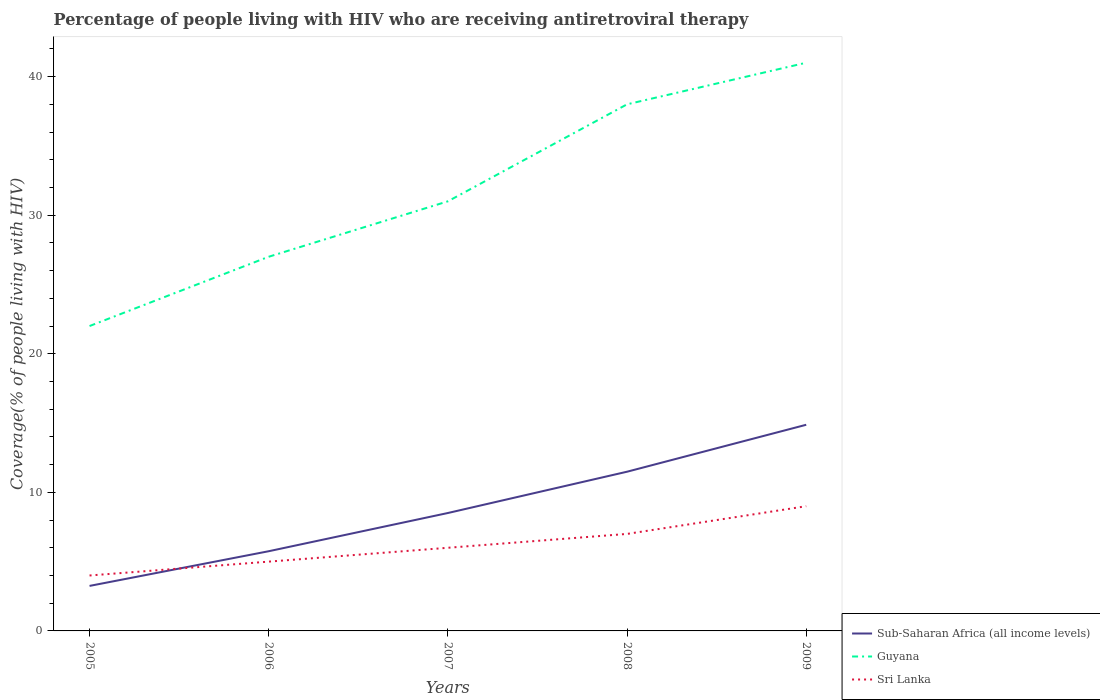Across all years, what is the maximum percentage of the HIV infected people who are receiving antiretroviral therapy in Sri Lanka?
Offer a terse response. 4. What is the total percentage of the HIV infected people who are receiving antiretroviral therapy in Sub-Saharan Africa (all income levels) in the graph?
Your response must be concise. -2.98. What is the difference between the highest and the second highest percentage of the HIV infected people who are receiving antiretroviral therapy in Sri Lanka?
Your response must be concise. 5. Is the percentage of the HIV infected people who are receiving antiretroviral therapy in Sri Lanka strictly greater than the percentage of the HIV infected people who are receiving antiretroviral therapy in Guyana over the years?
Keep it short and to the point. Yes. How many lines are there?
Your answer should be very brief. 3. What is the difference between two consecutive major ticks on the Y-axis?
Make the answer very short. 10. Are the values on the major ticks of Y-axis written in scientific E-notation?
Offer a very short reply. No. Does the graph contain any zero values?
Your answer should be very brief. No. How many legend labels are there?
Offer a very short reply. 3. What is the title of the graph?
Give a very brief answer. Percentage of people living with HIV who are receiving antiretroviral therapy. What is the label or title of the X-axis?
Make the answer very short. Years. What is the label or title of the Y-axis?
Offer a terse response. Coverage(% of people living with HIV). What is the Coverage(% of people living with HIV) in Sub-Saharan Africa (all income levels) in 2005?
Offer a terse response. 3.25. What is the Coverage(% of people living with HIV) of Sub-Saharan Africa (all income levels) in 2006?
Your response must be concise. 5.75. What is the Coverage(% of people living with HIV) in Sub-Saharan Africa (all income levels) in 2007?
Offer a terse response. 8.51. What is the Coverage(% of people living with HIV) of Sri Lanka in 2007?
Provide a short and direct response. 6. What is the Coverage(% of people living with HIV) in Sub-Saharan Africa (all income levels) in 2008?
Provide a succinct answer. 11.49. What is the Coverage(% of people living with HIV) in Guyana in 2008?
Offer a terse response. 38. What is the Coverage(% of people living with HIV) in Sub-Saharan Africa (all income levels) in 2009?
Ensure brevity in your answer.  14.88. What is the Coverage(% of people living with HIV) in Sri Lanka in 2009?
Ensure brevity in your answer.  9. Across all years, what is the maximum Coverage(% of people living with HIV) in Sub-Saharan Africa (all income levels)?
Your answer should be compact. 14.88. Across all years, what is the minimum Coverage(% of people living with HIV) of Sub-Saharan Africa (all income levels)?
Give a very brief answer. 3.25. What is the total Coverage(% of people living with HIV) in Sub-Saharan Africa (all income levels) in the graph?
Provide a succinct answer. 43.87. What is the total Coverage(% of people living with HIV) of Guyana in the graph?
Give a very brief answer. 159. What is the total Coverage(% of people living with HIV) in Sri Lanka in the graph?
Keep it short and to the point. 31. What is the difference between the Coverage(% of people living with HIV) of Sub-Saharan Africa (all income levels) in 2005 and that in 2006?
Your response must be concise. -2.5. What is the difference between the Coverage(% of people living with HIV) of Guyana in 2005 and that in 2006?
Provide a short and direct response. -5. What is the difference between the Coverage(% of people living with HIV) of Sri Lanka in 2005 and that in 2006?
Your answer should be very brief. -1. What is the difference between the Coverage(% of people living with HIV) of Sub-Saharan Africa (all income levels) in 2005 and that in 2007?
Your answer should be compact. -5.26. What is the difference between the Coverage(% of people living with HIV) of Sub-Saharan Africa (all income levels) in 2005 and that in 2008?
Offer a very short reply. -8.24. What is the difference between the Coverage(% of people living with HIV) in Sri Lanka in 2005 and that in 2008?
Your response must be concise. -3. What is the difference between the Coverage(% of people living with HIV) in Sub-Saharan Africa (all income levels) in 2005 and that in 2009?
Make the answer very short. -11.63. What is the difference between the Coverage(% of people living with HIV) in Sri Lanka in 2005 and that in 2009?
Keep it short and to the point. -5. What is the difference between the Coverage(% of people living with HIV) of Sub-Saharan Africa (all income levels) in 2006 and that in 2007?
Provide a succinct answer. -2.76. What is the difference between the Coverage(% of people living with HIV) of Guyana in 2006 and that in 2007?
Make the answer very short. -4. What is the difference between the Coverage(% of people living with HIV) in Sub-Saharan Africa (all income levels) in 2006 and that in 2008?
Give a very brief answer. -5.74. What is the difference between the Coverage(% of people living with HIV) of Guyana in 2006 and that in 2008?
Provide a short and direct response. -11. What is the difference between the Coverage(% of people living with HIV) of Sub-Saharan Africa (all income levels) in 2006 and that in 2009?
Your response must be concise. -9.12. What is the difference between the Coverage(% of people living with HIV) of Guyana in 2006 and that in 2009?
Your response must be concise. -14. What is the difference between the Coverage(% of people living with HIV) in Sub-Saharan Africa (all income levels) in 2007 and that in 2008?
Keep it short and to the point. -2.98. What is the difference between the Coverage(% of people living with HIV) of Guyana in 2007 and that in 2008?
Make the answer very short. -7. What is the difference between the Coverage(% of people living with HIV) in Sri Lanka in 2007 and that in 2008?
Offer a very short reply. -1. What is the difference between the Coverage(% of people living with HIV) of Sub-Saharan Africa (all income levels) in 2007 and that in 2009?
Give a very brief answer. -6.37. What is the difference between the Coverage(% of people living with HIV) of Guyana in 2007 and that in 2009?
Make the answer very short. -10. What is the difference between the Coverage(% of people living with HIV) of Sri Lanka in 2007 and that in 2009?
Offer a terse response. -3. What is the difference between the Coverage(% of people living with HIV) of Sub-Saharan Africa (all income levels) in 2008 and that in 2009?
Give a very brief answer. -3.39. What is the difference between the Coverage(% of people living with HIV) of Guyana in 2008 and that in 2009?
Provide a short and direct response. -3. What is the difference between the Coverage(% of people living with HIV) in Sri Lanka in 2008 and that in 2009?
Provide a succinct answer. -2. What is the difference between the Coverage(% of people living with HIV) of Sub-Saharan Africa (all income levels) in 2005 and the Coverage(% of people living with HIV) of Guyana in 2006?
Provide a short and direct response. -23.75. What is the difference between the Coverage(% of people living with HIV) of Sub-Saharan Africa (all income levels) in 2005 and the Coverage(% of people living with HIV) of Sri Lanka in 2006?
Provide a succinct answer. -1.75. What is the difference between the Coverage(% of people living with HIV) in Sub-Saharan Africa (all income levels) in 2005 and the Coverage(% of people living with HIV) in Guyana in 2007?
Provide a succinct answer. -27.75. What is the difference between the Coverage(% of people living with HIV) in Sub-Saharan Africa (all income levels) in 2005 and the Coverage(% of people living with HIV) in Sri Lanka in 2007?
Ensure brevity in your answer.  -2.75. What is the difference between the Coverage(% of people living with HIV) of Guyana in 2005 and the Coverage(% of people living with HIV) of Sri Lanka in 2007?
Offer a very short reply. 16. What is the difference between the Coverage(% of people living with HIV) of Sub-Saharan Africa (all income levels) in 2005 and the Coverage(% of people living with HIV) of Guyana in 2008?
Provide a succinct answer. -34.75. What is the difference between the Coverage(% of people living with HIV) of Sub-Saharan Africa (all income levels) in 2005 and the Coverage(% of people living with HIV) of Sri Lanka in 2008?
Your response must be concise. -3.75. What is the difference between the Coverage(% of people living with HIV) of Sub-Saharan Africa (all income levels) in 2005 and the Coverage(% of people living with HIV) of Guyana in 2009?
Offer a very short reply. -37.75. What is the difference between the Coverage(% of people living with HIV) in Sub-Saharan Africa (all income levels) in 2005 and the Coverage(% of people living with HIV) in Sri Lanka in 2009?
Keep it short and to the point. -5.75. What is the difference between the Coverage(% of people living with HIV) of Sub-Saharan Africa (all income levels) in 2006 and the Coverage(% of people living with HIV) of Guyana in 2007?
Offer a very short reply. -25.25. What is the difference between the Coverage(% of people living with HIV) of Sub-Saharan Africa (all income levels) in 2006 and the Coverage(% of people living with HIV) of Sri Lanka in 2007?
Provide a succinct answer. -0.25. What is the difference between the Coverage(% of people living with HIV) in Sub-Saharan Africa (all income levels) in 2006 and the Coverage(% of people living with HIV) in Guyana in 2008?
Give a very brief answer. -32.25. What is the difference between the Coverage(% of people living with HIV) in Sub-Saharan Africa (all income levels) in 2006 and the Coverage(% of people living with HIV) in Sri Lanka in 2008?
Offer a very short reply. -1.25. What is the difference between the Coverage(% of people living with HIV) of Sub-Saharan Africa (all income levels) in 2006 and the Coverage(% of people living with HIV) of Guyana in 2009?
Offer a very short reply. -35.25. What is the difference between the Coverage(% of people living with HIV) in Sub-Saharan Africa (all income levels) in 2006 and the Coverage(% of people living with HIV) in Sri Lanka in 2009?
Offer a terse response. -3.25. What is the difference between the Coverage(% of people living with HIV) in Sub-Saharan Africa (all income levels) in 2007 and the Coverage(% of people living with HIV) in Guyana in 2008?
Provide a succinct answer. -29.49. What is the difference between the Coverage(% of people living with HIV) of Sub-Saharan Africa (all income levels) in 2007 and the Coverage(% of people living with HIV) of Sri Lanka in 2008?
Keep it short and to the point. 1.51. What is the difference between the Coverage(% of people living with HIV) in Sub-Saharan Africa (all income levels) in 2007 and the Coverage(% of people living with HIV) in Guyana in 2009?
Give a very brief answer. -32.49. What is the difference between the Coverage(% of people living with HIV) of Sub-Saharan Africa (all income levels) in 2007 and the Coverage(% of people living with HIV) of Sri Lanka in 2009?
Provide a short and direct response. -0.49. What is the difference between the Coverage(% of people living with HIV) in Sub-Saharan Africa (all income levels) in 2008 and the Coverage(% of people living with HIV) in Guyana in 2009?
Your response must be concise. -29.51. What is the difference between the Coverage(% of people living with HIV) in Sub-Saharan Africa (all income levels) in 2008 and the Coverage(% of people living with HIV) in Sri Lanka in 2009?
Provide a succinct answer. 2.49. What is the average Coverage(% of people living with HIV) in Sub-Saharan Africa (all income levels) per year?
Make the answer very short. 8.77. What is the average Coverage(% of people living with HIV) in Guyana per year?
Give a very brief answer. 31.8. In the year 2005, what is the difference between the Coverage(% of people living with HIV) of Sub-Saharan Africa (all income levels) and Coverage(% of people living with HIV) of Guyana?
Offer a terse response. -18.75. In the year 2005, what is the difference between the Coverage(% of people living with HIV) of Sub-Saharan Africa (all income levels) and Coverage(% of people living with HIV) of Sri Lanka?
Give a very brief answer. -0.75. In the year 2005, what is the difference between the Coverage(% of people living with HIV) of Guyana and Coverage(% of people living with HIV) of Sri Lanka?
Offer a terse response. 18. In the year 2006, what is the difference between the Coverage(% of people living with HIV) in Sub-Saharan Africa (all income levels) and Coverage(% of people living with HIV) in Guyana?
Your answer should be compact. -21.25. In the year 2006, what is the difference between the Coverage(% of people living with HIV) of Sub-Saharan Africa (all income levels) and Coverage(% of people living with HIV) of Sri Lanka?
Offer a terse response. 0.75. In the year 2006, what is the difference between the Coverage(% of people living with HIV) in Guyana and Coverage(% of people living with HIV) in Sri Lanka?
Offer a very short reply. 22. In the year 2007, what is the difference between the Coverage(% of people living with HIV) of Sub-Saharan Africa (all income levels) and Coverage(% of people living with HIV) of Guyana?
Provide a short and direct response. -22.49. In the year 2007, what is the difference between the Coverage(% of people living with HIV) in Sub-Saharan Africa (all income levels) and Coverage(% of people living with HIV) in Sri Lanka?
Your response must be concise. 2.51. In the year 2007, what is the difference between the Coverage(% of people living with HIV) in Guyana and Coverage(% of people living with HIV) in Sri Lanka?
Offer a terse response. 25. In the year 2008, what is the difference between the Coverage(% of people living with HIV) of Sub-Saharan Africa (all income levels) and Coverage(% of people living with HIV) of Guyana?
Offer a very short reply. -26.51. In the year 2008, what is the difference between the Coverage(% of people living with HIV) in Sub-Saharan Africa (all income levels) and Coverage(% of people living with HIV) in Sri Lanka?
Ensure brevity in your answer.  4.49. In the year 2008, what is the difference between the Coverage(% of people living with HIV) in Guyana and Coverage(% of people living with HIV) in Sri Lanka?
Provide a short and direct response. 31. In the year 2009, what is the difference between the Coverage(% of people living with HIV) in Sub-Saharan Africa (all income levels) and Coverage(% of people living with HIV) in Guyana?
Offer a terse response. -26.12. In the year 2009, what is the difference between the Coverage(% of people living with HIV) in Sub-Saharan Africa (all income levels) and Coverage(% of people living with HIV) in Sri Lanka?
Give a very brief answer. 5.88. In the year 2009, what is the difference between the Coverage(% of people living with HIV) in Guyana and Coverage(% of people living with HIV) in Sri Lanka?
Give a very brief answer. 32. What is the ratio of the Coverage(% of people living with HIV) of Sub-Saharan Africa (all income levels) in 2005 to that in 2006?
Your response must be concise. 0.56. What is the ratio of the Coverage(% of people living with HIV) in Guyana in 2005 to that in 2006?
Keep it short and to the point. 0.81. What is the ratio of the Coverage(% of people living with HIV) of Sri Lanka in 2005 to that in 2006?
Provide a succinct answer. 0.8. What is the ratio of the Coverage(% of people living with HIV) in Sub-Saharan Africa (all income levels) in 2005 to that in 2007?
Offer a terse response. 0.38. What is the ratio of the Coverage(% of people living with HIV) in Guyana in 2005 to that in 2007?
Offer a terse response. 0.71. What is the ratio of the Coverage(% of people living with HIV) in Sub-Saharan Africa (all income levels) in 2005 to that in 2008?
Provide a short and direct response. 0.28. What is the ratio of the Coverage(% of people living with HIV) of Guyana in 2005 to that in 2008?
Your answer should be compact. 0.58. What is the ratio of the Coverage(% of people living with HIV) of Sub-Saharan Africa (all income levels) in 2005 to that in 2009?
Offer a terse response. 0.22. What is the ratio of the Coverage(% of people living with HIV) of Guyana in 2005 to that in 2009?
Offer a very short reply. 0.54. What is the ratio of the Coverage(% of people living with HIV) in Sri Lanka in 2005 to that in 2009?
Offer a very short reply. 0.44. What is the ratio of the Coverage(% of people living with HIV) of Sub-Saharan Africa (all income levels) in 2006 to that in 2007?
Offer a very short reply. 0.68. What is the ratio of the Coverage(% of people living with HIV) of Guyana in 2006 to that in 2007?
Ensure brevity in your answer.  0.87. What is the ratio of the Coverage(% of people living with HIV) in Sub-Saharan Africa (all income levels) in 2006 to that in 2008?
Your answer should be very brief. 0.5. What is the ratio of the Coverage(% of people living with HIV) of Guyana in 2006 to that in 2008?
Give a very brief answer. 0.71. What is the ratio of the Coverage(% of people living with HIV) of Sri Lanka in 2006 to that in 2008?
Give a very brief answer. 0.71. What is the ratio of the Coverage(% of people living with HIV) of Sub-Saharan Africa (all income levels) in 2006 to that in 2009?
Make the answer very short. 0.39. What is the ratio of the Coverage(% of people living with HIV) in Guyana in 2006 to that in 2009?
Make the answer very short. 0.66. What is the ratio of the Coverage(% of people living with HIV) of Sri Lanka in 2006 to that in 2009?
Keep it short and to the point. 0.56. What is the ratio of the Coverage(% of people living with HIV) of Sub-Saharan Africa (all income levels) in 2007 to that in 2008?
Offer a very short reply. 0.74. What is the ratio of the Coverage(% of people living with HIV) in Guyana in 2007 to that in 2008?
Your response must be concise. 0.82. What is the ratio of the Coverage(% of people living with HIV) of Sub-Saharan Africa (all income levels) in 2007 to that in 2009?
Keep it short and to the point. 0.57. What is the ratio of the Coverage(% of people living with HIV) in Guyana in 2007 to that in 2009?
Your response must be concise. 0.76. What is the ratio of the Coverage(% of people living with HIV) of Sri Lanka in 2007 to that in 2009?
Offer a very short reply. 0.67. What is the ratio of the Coverage(% of people living with HIV) of Sub-Saharan Africa (all income levels) in 2008 to that in 2009?
Keep it short and to the point. 0.77. What is the ratio of the Coverage(% of people living with HIV) in Guyana in 2008 to that in 2009?
Your response must be concise. 0.93. What is the ratio of the Coverage(% of people living with HIV) in Sri Lanka in 2008 to that in 2009?
Your response must be concise. 0.78. What is the difference between the highest and the second highest Coverage(% of people living with HIV) of Sub-Saharan Africa (all income levels)?
Offer a terse response. 3.39. What is the difference between the highest and the lowest Coverage(% of people living with HIV) of Sub-Saharan Africa (all income levels)?
Your answer should be very brief. 11.63. What is the difference between the highest and the lowest Coverage(% of people living with HIV) of Guyana?
Make the answer very short. 19. What is the difference between the highest and the lowest Coverage(% of people living with HIV) in Sri Lanka?
Your answer should be compact. 5. 